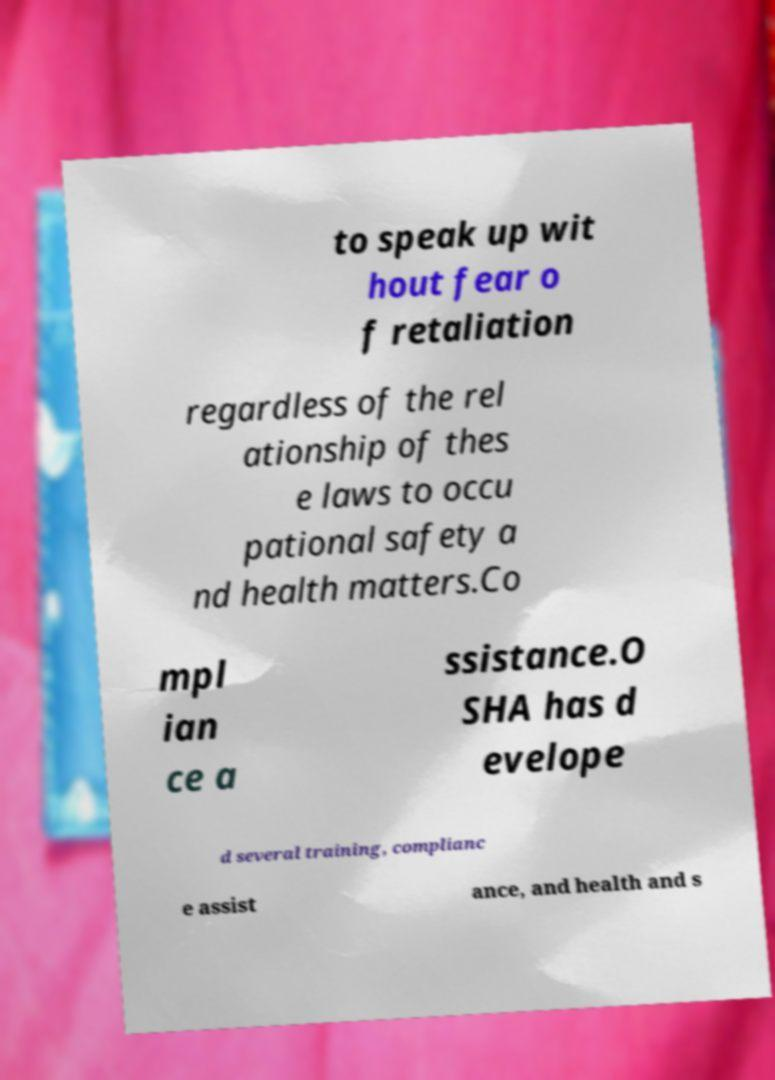I need the written content from this picture converted into text. Can you do that? to speak up wit hout fear o f retaliation regardless of the rel ationship of thes e laws to occu pational safety a nd health matters.Co mpl ian ce a ssistance.O SHA has d evelope d several training, complianc e assist ance, and health and s 